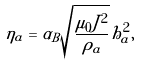Convert formula to latex. <formula><loc_0><loc_0><loc_500><loc_500>\eta _ { a } = \alpha _ { B } \sqrt { \frac { \mu _ { 0 } J ^ { 2 } } { \rho _ { a } } } h ^ { 2 } _ { a } ,</formula> 